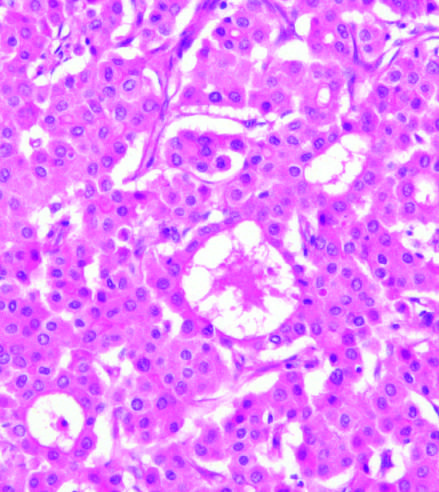how did malignant hepatocytes grow?
Answer the question using a single word or phrase. In distorted versions of normal architecture 